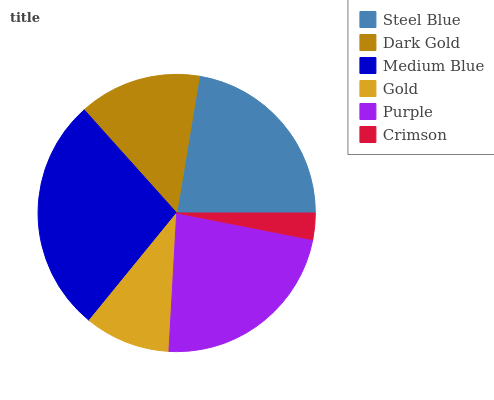Is Crimson the minimum?
Answer yes or no. Yes. Is Medium Blue the maximum?
Answer yes or no. Yes. Is Dark Gold the minimum?
Answer yes or no. No. Is Dark Gold the maximum?
Answer yes or no. No. Is Steel Blue greater than Dark Gold?
Answer yes or no. Yes. Is Dark Gold less than Steel Blue?
Answer yes or no. Yes. Is Dark Gold greater than Steel Blue?
Answer yes or no. No. Is Steel Blue less than Dark Gold?
Answer yes or no. No. Is Steel Blue the high median?
Answer yes or no. Yes. Is Dark Gold the low median?
Answer yes or no. Yes. Is Crimson the high median?
Answer yes or no. No. Is Crimson the low median?
Answer yes or no. No. 